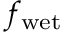<formula> <loc_0><loc_0><loc_500><loc_500>f _ { w e t }</formula> 